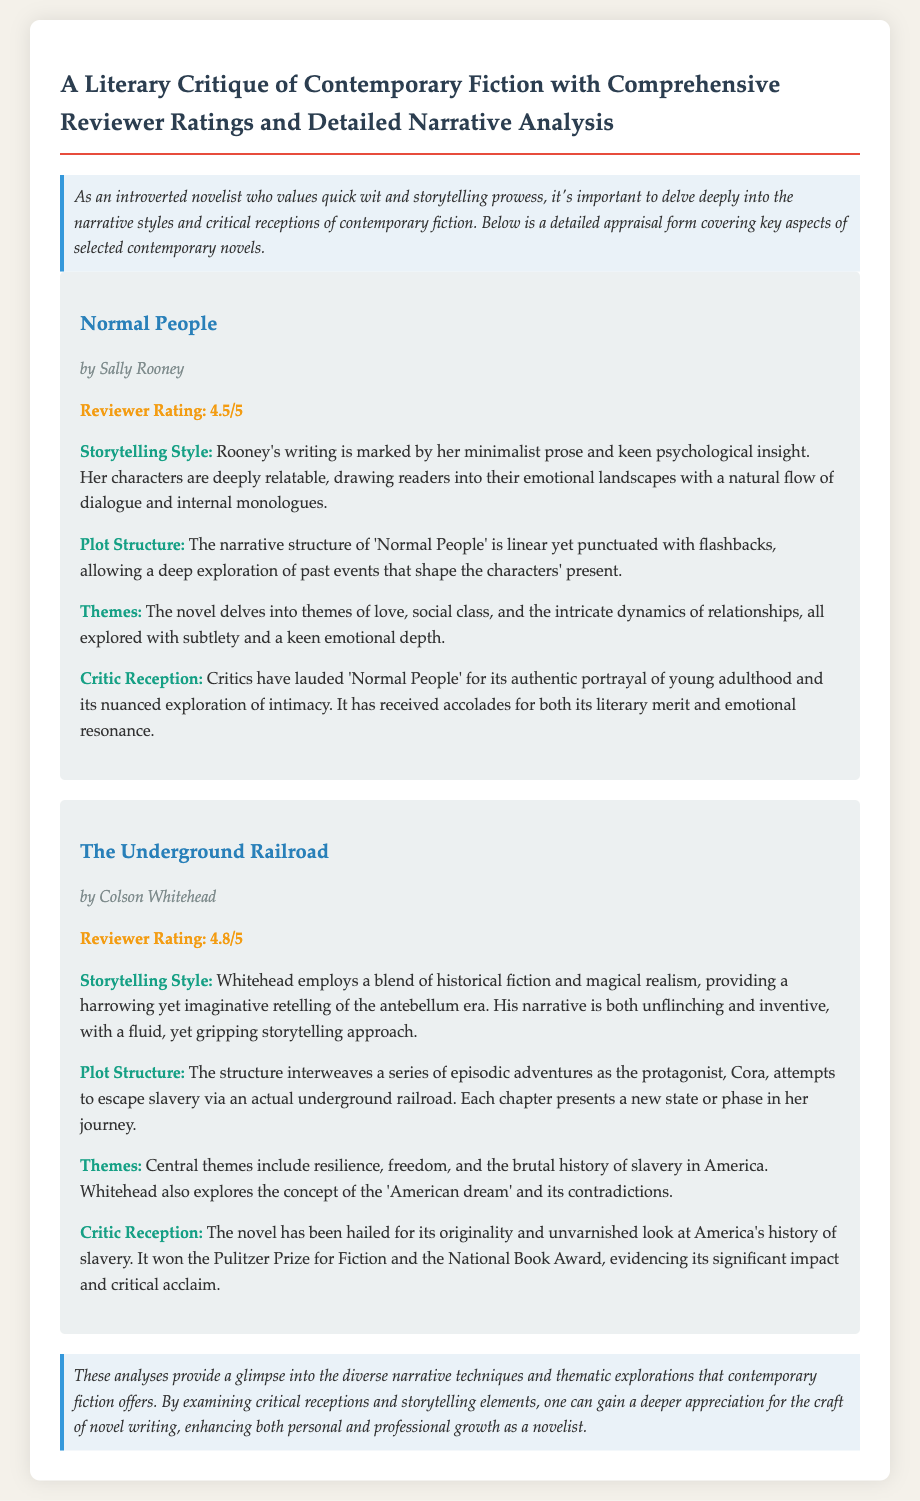What is the title of the first book reviewed? The title of the first book reviewed in the document is "Normal People."
Answer: Normal People Who is the author of "The Underground Railroad"? The author of "The Underground Railroad" is Colson Whitehead.
Answer: Colson Whitehead What is the reviewer rating for "Normal People"? The reviewer rating provided for "Normal People" is 4.5 out of 5.
Answer: 4.5/5 What theme is explored in "The Underground Railroad"? One of the central themes explored in "The Underground Railroad" is freedom.
Answer: Freedom What narrative style is used by Sally Rooney in "Normal People"? Sally Rooney's narrative style in "Normal People" is minimalist prose.
Answer: Minimalist prose Which award did "The Underground Railroad" win? "The Underground Railroad" won the Pulitzer Prize for Fiction.
Answer: Pulitzer Prize for Fiction What is the primary focus of the critiques in the document? The primary focus of the critiques is on narrative styles and critical receptions of contemporary fiction.
Answer: Narrative styles and critical receptions How does Colson Whitehead describe his storytelling approach? Colson Whitehead's storytelling approach is described as unflinching and inventive.
Answer: Unflinching and inventive What overall message is suggested for novelists at the end of the document? The overall message suggested for novelists is to gain deeper appreciation for the craft of novel writing.
Answer: Gain deeper appreciation for the craft 